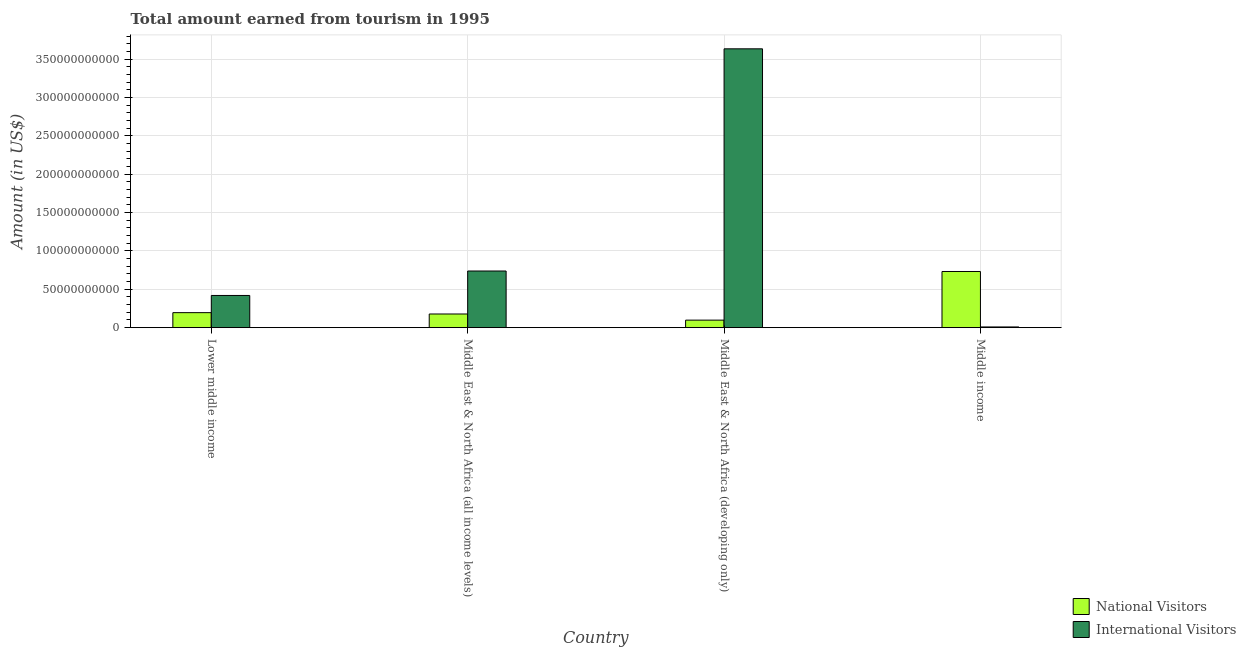How many different coloured bars are there?
Your response must be concise. 2. How many bars are there on the 1st tick from the right?
Your answer should be compact. 2. What is the amount earned from international visitors in Middle East & North Africa (developing only)?
Give a very brief answer. 3.64e+11. Across all countries, what is the maximum amount earned from national visitors?
Provide a short and direct response. 7.33e+1. Across all countries, what is the minimum amount earned from international visitors?
Give a very brief answer. 9.29e+08. In which country was the amount earned from national visitors maximum?
Offer a very short reply. Middle income. What is the total amount earned from international visitors in the graph?
Give a very brief answer. 4.81e+11. What is the difference between the amount earned from national visitors in Middle East & North Africa (all income levels) and that in Middle income?
Offer a very short reply. -5.54e+1. What is the difference between the amount earned from international visitors in Middle income and the amount earned from national visitors in Middle East & North Africa (all income levels)?
Your answer should be very brief. -1.69e+1. What is the average amount earned from international visitors per country?
Keep it short and to the point. 1.20e+11. What is the difference between the amount earned from international visitors and amount earned from national visitors in Lower middle income?
Offer a terse response. 2.24e+1. What is the ratio of the amount earned from national visitors in Lower middle income to that in Middle East & North Africa (developing only)?
Your response must be concise. 2. Is the difference between the amount earned from international visitors in Lower middle income and Middle East & North Africa (developing only) greater than the difference between the amount earned from national visitors in Lower middle income and Middle East & North Africa (developing only)?
Keep it short and to the point. No. What is the difference between the highest and the second highest amount earned from international visitors?
Your response must be concise. 2.90e+11. What is the difference between the highest and the lowest amount earned from international visitors?
Your response must be concise. 3.63e+11. In how many countries, is the amount earned from national visitors greater than the average amount earned from national visitors taken over all countries?
Your response must be concise. 1. What does the 2nd bar from the left in Lower middle income represents?
Provide a short and direct response. International Visitors. What does the 2nd bar from the right in Middle income represents?
Your answer should be compact. National Visitors. Are all the bars in the graph horizontal?
Offer a very short reply. No. Does the graph contain grids?
Your response must be concise. Yes. How are the legend labels stacked?
Offer a very short reply. Vertical. What is the title of the graph?
Your answer should be very brief. Total amount earned from tourism in 1995. Does "Merchandise imports" appear as one of the legend labels in the graph?
Provide a short and direct response. No. What is the label or title of the Y-axis?
Make the answer very short. Amount (in US$). What is the Amount (in US$) in National Visitors in Lower middle income?
Offer a very short reply. 1.96e+1. What is the Amount (in US$) in International Visitors in Lower middle income?
Ensure brevity in your answer.  4.20e+1. What is the Amount (in US$) in National Visitors in Middle East & North Africa (all income levels)?
Give a very brief answer. 1.78e+1. What is the Amount (in US$) in International Visitors in Middle East & North Africa (all income levels)?
Your answer should be very brief. 7.39e+1. What is the Amount (in US$) in National Visitors in Middle East & North Africa (developing only)?
Offer a terse response. 9.81e+09. What is the Amount (in US$) in International Visitors in Middle East & North Africa (developing only)?
Your response must be concise. 3.64e+11. What is the Amount (in US$) in National Visitors in Middle income?
Make the answer very short. 7.33e+1. What is the Amount (in US$) of International Visitors in Middle income?
Make the answer very short. 9.29e+08. Across all countries, what is the maximum Amount (in US$) in National Visitors?
Your answer should be very brief. 7.33e+1. Across all countries, what is the maximum Amount (in US$) of International Visitors?
Offer a very short reply. 3.64e+11. Across all countries, what is the minimum Amount (in US$) of National Visitors?
Provide a short and direct response. 9.81e+09. Across all countries, what is the minimum Amount (in US$) in International Visitors?
Your answer should be compact. 9.29e+08. What is the total Amount (in US$) of National Visitors in the graph?
Provide a short and direct response. 1.20e+11. What is the total Amount (in US$) in International Visitors in the graph?
Keep it short and to the point. 4.81e+11. What is the difference between the Amount (in US$) in National Visitors in Lower middle income and that in Middle East & North Africa (all income levels)?
Make the answer very short. 1.76e+09. What is the difference between the Amount (in US$) in International Visitors in Lower middle income and that in Middle East & North Africa (all income levels)?
Offer a terse response. -3.19e+1. What is the difference between the Amount (in US$) of National Visitors in Lower middle income and that in Middle East & North Africa (developing only)?
Your answer should be very brief. 9.78e+09. What is the difference between the Amount (in US$) of International Visitors in Lower middle income and that in Middle East & North Africa (developing only)?
Give a very brief answer. -3.22e+11. What is the difference between the Amount (in US$) in National Visitors in Lower middle income and that in Middle income?
Ensure brevity in your answer.  -5.37e+1. What is the difference between the Amount (in US$) of International Visitors in Lower middle income and that in Middle income?
Ensure brevity in your answer.  4.11e+1. What is the difference between the Amount (in US$) of National Visitors in Middle East & North Africa (all income levels) and that in Middle East & North Africa (developing only)?
Provide a succinct answer. 8.02e+09. What is the difference between the Amount (in US$) of International Visitors in Middle East & North Africa (all income levels) and that in Middle East & North Africa (developing only)?
Ensure brevity in your answer.  -2.90e+11. What is the difference between the Amount (in US$) in National Visitors in Middle East & North Africa (all income levels) and that in Middle income?
Make the answer very short. -5.54e+1. What is the difference between the Amount (in US$) of International Visitors in Middle East & North Africa (all income levels) and that in Middle income?
Keep it short and to the point. 7.30e+1. What is the difference between the Amount (in US$) in National Visitors in Middle East & North Africa (developing only) and that in Middle income?
Provide a succinct answer. -6.34e+1. What is the difference between the Amount (in US$) in International Visitors in Middle East & North Africa (developing only) and that in Middle income?
Offer a terse response. 3.63e+11. What is the difference between the Amount (in US$) of National Visitors in Lower middle income and the Amount (in US$) of International Visitors in Middle East & North Africa (all income levels)?
Ensure brevity in your answer.  -5.43e+1. What is the difference between the Amount (in US$) of National Visitors in Lower middle income and the Amount (in US$) of International Visitors in Middle East & North Africa (developing only)?
Provide a succinct answer. -3.44e+11. What is the difference between the Amount (in US$) of National Visitors in Lower middle income and the Amount (in US$) of International Visitors in Middle income?
Offer a terse response. 1.87e+1. What is the difference between the Amount (in US$) in National Visitors in Middle East & North Africa (all income levels) and the Amount (in US$) in International Visitors in Middle East & North Africa (developing only)?
Give a very brief answer. -3.46e+11. What is the difference between the Amount (in US$) in National Visitors in Middle East & North Africa (all income levels) and the Amount (in US$) in International Visitors in Middle income?
Give a very brief answer. 1.69e+1. What is the difference between the Amount (in US$) in National Visitors in Middle East & North Africa (developing only) and the Amount (in US$) in International Visitors in Middle income?
Give a very brief answer. 8.88e+09. What is the average Amount (in US$) of National Visitors per country?
Keep it short and to the point. 3.01e+1. What is the average Amount (in US$) of International Visitors per country?
Make the answer very short. 1.20e+11. What is the difference between the Amount (in US$) in National Visitors and Amount (in US$) in International Visitors in Lower middle income?
Your answer should be compact. -2.24e+1. What is the difference between the Amount (in US$) of National Visitors and Amount (in US$) of International Visitors in Middle East & North Africa (all income levels)?
Provide a succinct answer. -5.61e+1. What is the difference between the Amount (in US$) in National Visitors and Amount (in US$) in International Visitors in Middle East & North Africa (developing only)?
Give a very brief answer. -3.54e+11. What is the difference between the Amount (in US$) of National Visitors and Amount (in US$) of International Visitors in Middle income?
Your answer should be very brief. 7.23e+1. What is the ratio of the Amount (in US$) in National Visitors in Lower middle income to that in Middle East & North Africa (all income levels)?
Offer a terse response. 1.1. What is the ratio of the Amount (in US$) in International Visitors in Lower middle income to that in Middle East & North Africa (all income levels)?
Provide a short and direct response. 0.57. What is the ratio of the Amount (in US$) in National Visitors in Lower middle income to that in Middle East & North Africa (developing only)?
Make the answer very short. 2. What is the ratio of the Amount (in US$) of International Visitors in Lower middle income to that in Middle East & North Africa (developing only)?
Offer a very short reply. 0.12. What is the ratio of the Amount (in US$) in National Visitors in Lower middle income to that in Middle income?
Offer a very short reply. 0.27. What is the ratio of the Amount (in US$) of International Visitors in Lower middle income to that in Middle income?
Offer a very short reply. 45.23. What is the ratio of the Amount (in US$) of National Visitors in Middle East & North Africa (all income levels) to that in Middle East & North Africa (developing only)?
Make the answer very short. 1.82. What is the ratio of the Amount (in US$) of International Visitors in Middle East & North Africa (all income levels) to that in Middle East & North Africa (developing only)?
Your answer should be compact. 0.2. What is the ratio of the Amount (in US$) of National Visitors in Middle East & North Africa (all income levels) to that in Middle income?
Your answer should be very brief. 0.24. What is the ratio of the Amount (in US$) of International Visitors in Middle East & North Africa (all income levels) to that in Middle income?
Your response must be concise. 79.56. What is the ratio of the Amount (in US$) of National Visitors in Middle East & North Africa (developing only) to that in Middle income?
Your answer should be very brief. 0.13. What is the ratio of the Amount (in US$) in International Visitors in Middle East & North Africa (developing only) to that in Middle income?
Provide a succinct answer. 391.62. What is the difference between the highest and the second highest Amount (in US$) in National Visitors?
Your answer should be compact. 5.37e+1. What is the difference between the highest and the second highest Amount (in US$) of International Visitors?
Provide a short and direct response. 2.90e+11. What is the difference between the highest and the lowest Amount (in US$) in National Visitors?
Provide a succinct answer. 6.34e+1. What is the difference between the highest and the lowest Amount (in US$) in International Visitors?
Ensure brevity in your answer.  3.63e+11. 